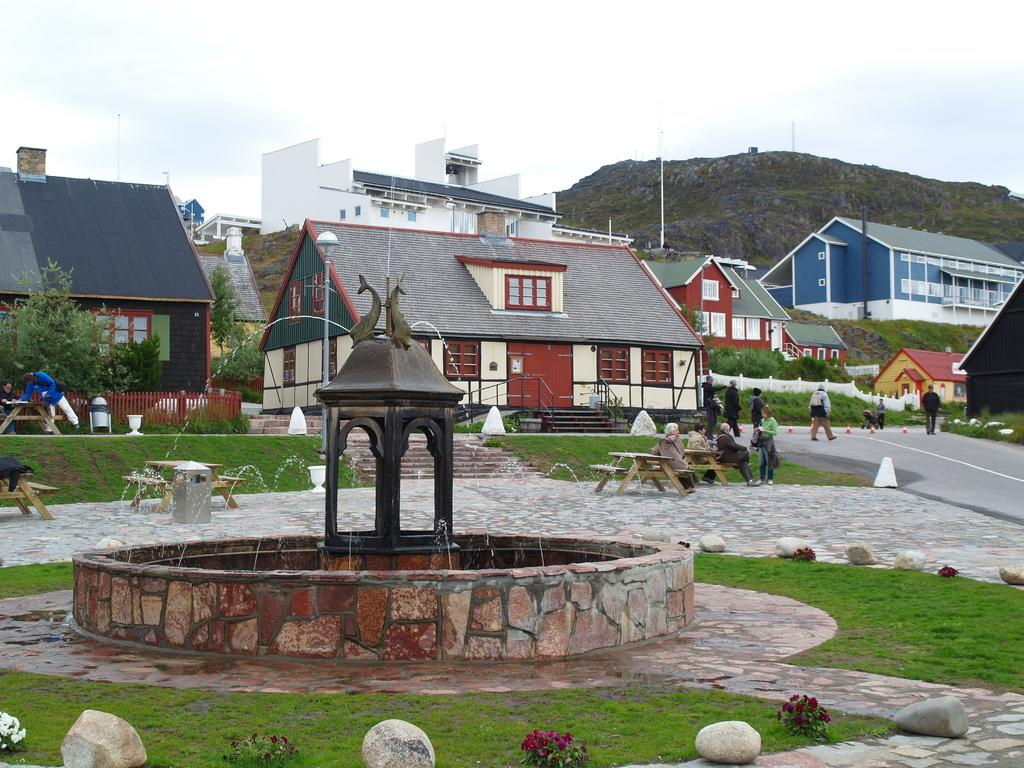What type of structures can be seen in the image? There are houses in the image. What else is visible on the ground in the image? There are people on the road in the image. What natural element is present in the image? There is water visible in the image. What is visible above the houses and people in the image? The sky is visible in the image. What type of station can be seen in the image? There is no station present in the image. How does the air affect the people walking on the road in the image? The image does not provide information about the air or its effects on the people walking on the road. 